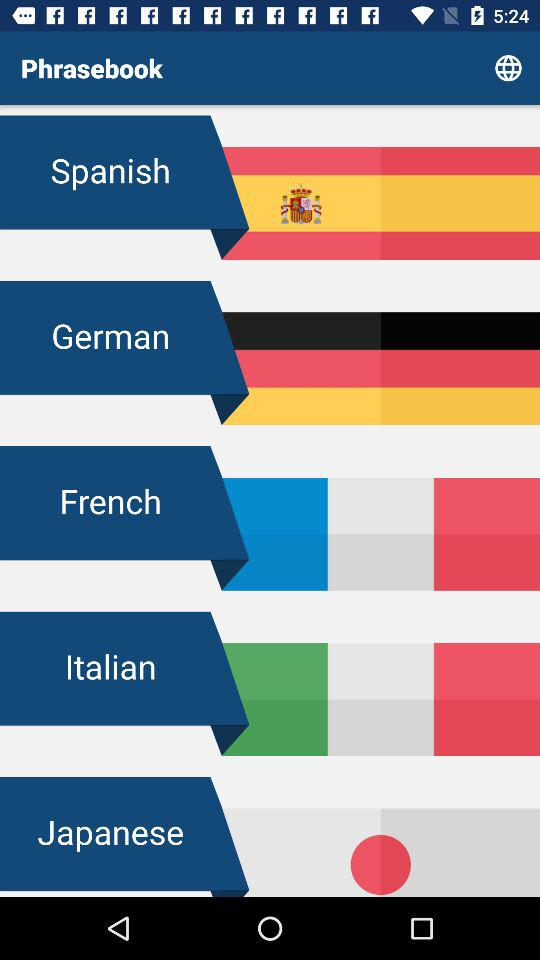How many languages have a red circle with a white border?
Answer the question using a single word or phrase. 1 